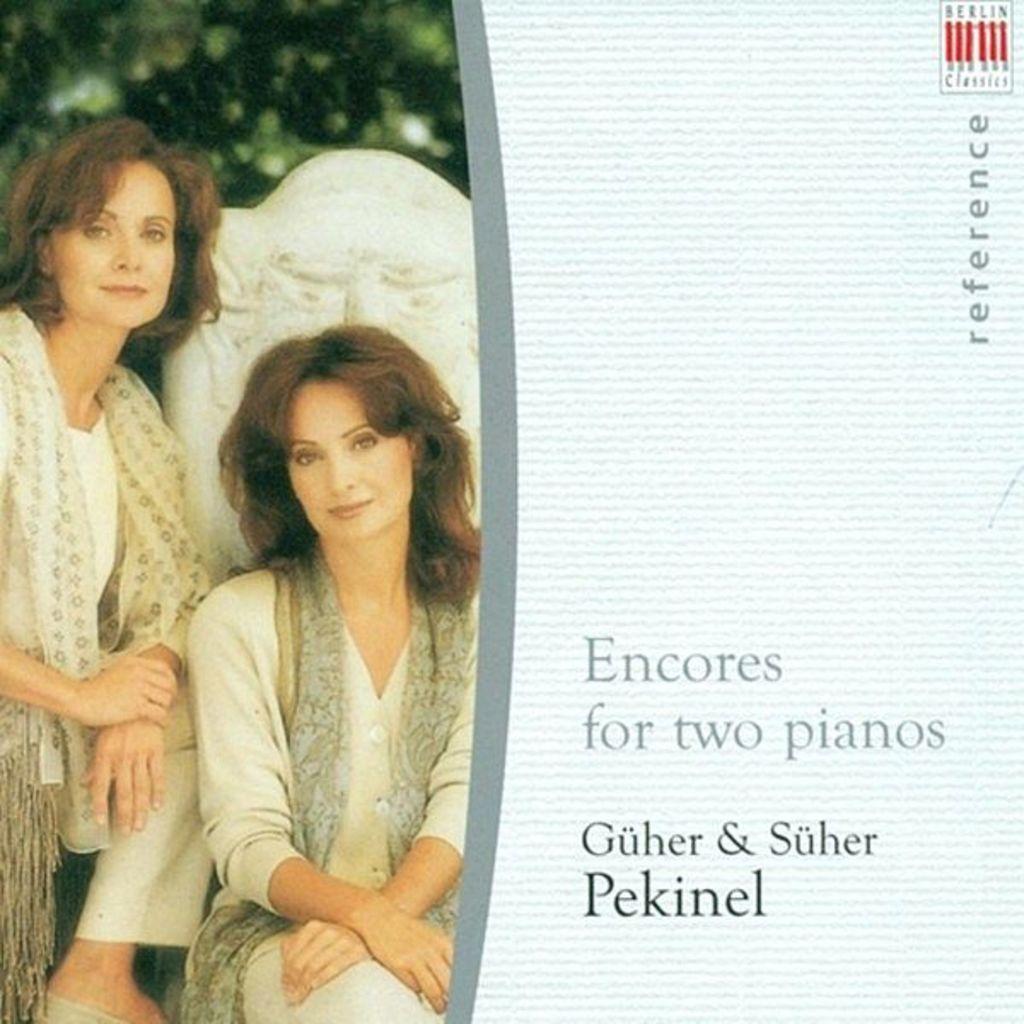In one or two sentences, can you explain what this image depicts? In this image I can see two women and I can see both of them are wearing white dress. In the background I can see green colour and I can see this image is little bit blurry from background. On right side of this image I can see something is written. 